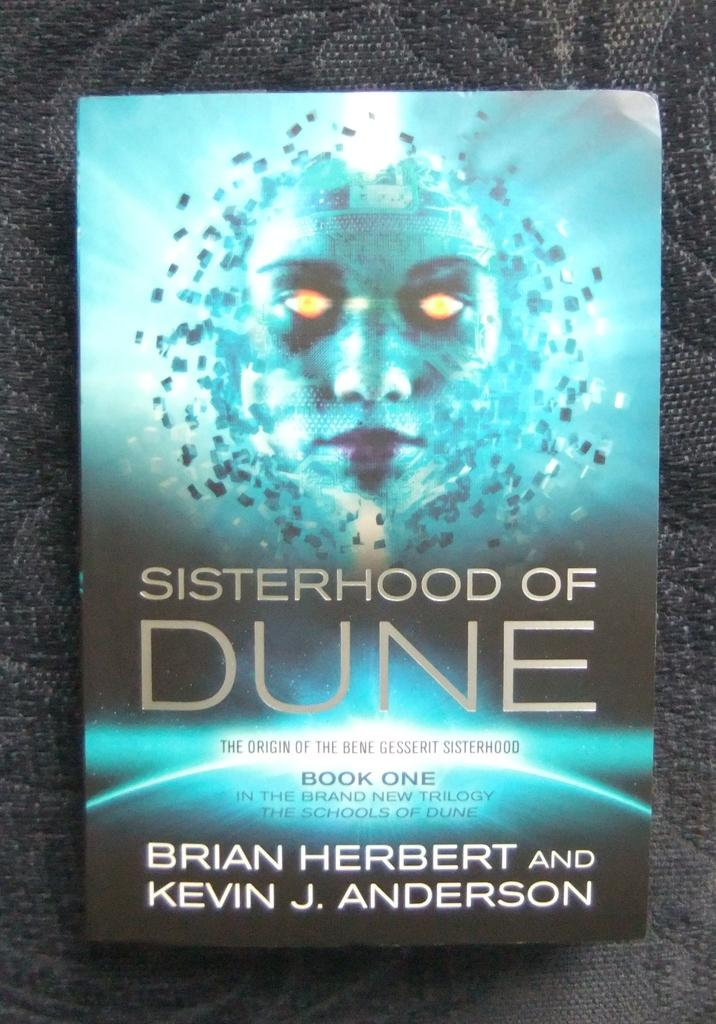<image>
Render a clear and concise summary of the photo. Cover of a book named Sisterhood of Dune with a blue face on the front. 